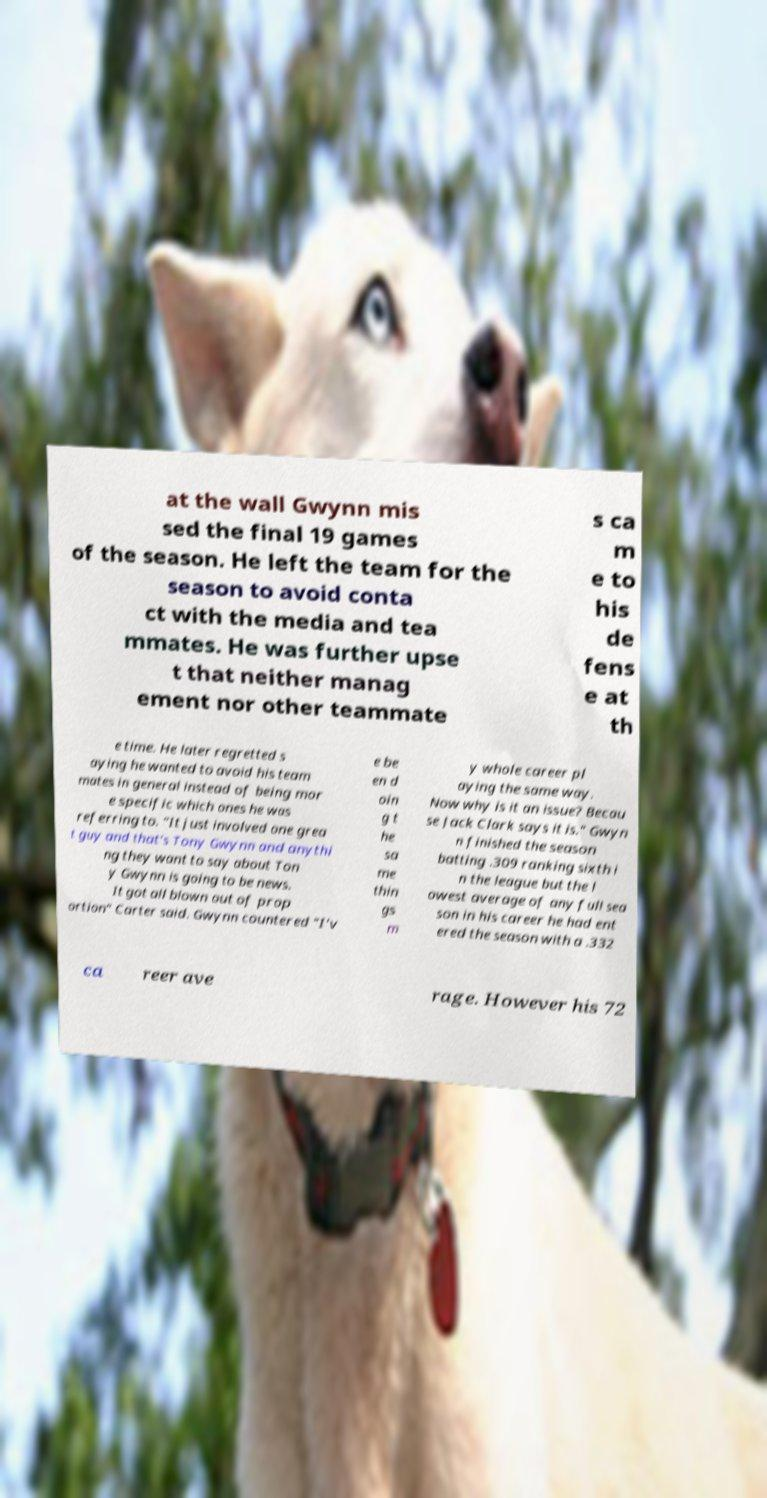I need the written content from this picture converted into text. Can you do that? at the wall Gwynn mis sed the final 19 games of the season. He left the team for the season to avoid conta ct with the media and tea mmates. He was further upse t that neither manag ement nor other teammate s ca m e to his de fens e at th e time. He later regretted s aying he wanted to avoid his team mates in general instead of being mor e specific which ones he was referring to. "It just involved one grea t guy and that's Tony Gwynn and anythi ng they want to say about Ton y Gwynn is going to be news. It got all blown out of prop ortion" Carter said. Gwynn countered "I'v e be en d oin g t he sa me thin gs m y whole career pl aying the same way. Now why is it an issue? Becau se Jack Clark says it is." Gwyn n finished the season batting .309 ranking sixth i n the league but the l owest average of any full sea son in his career he had ent ered the season with a .332 ca reer ave rage. However his 72 